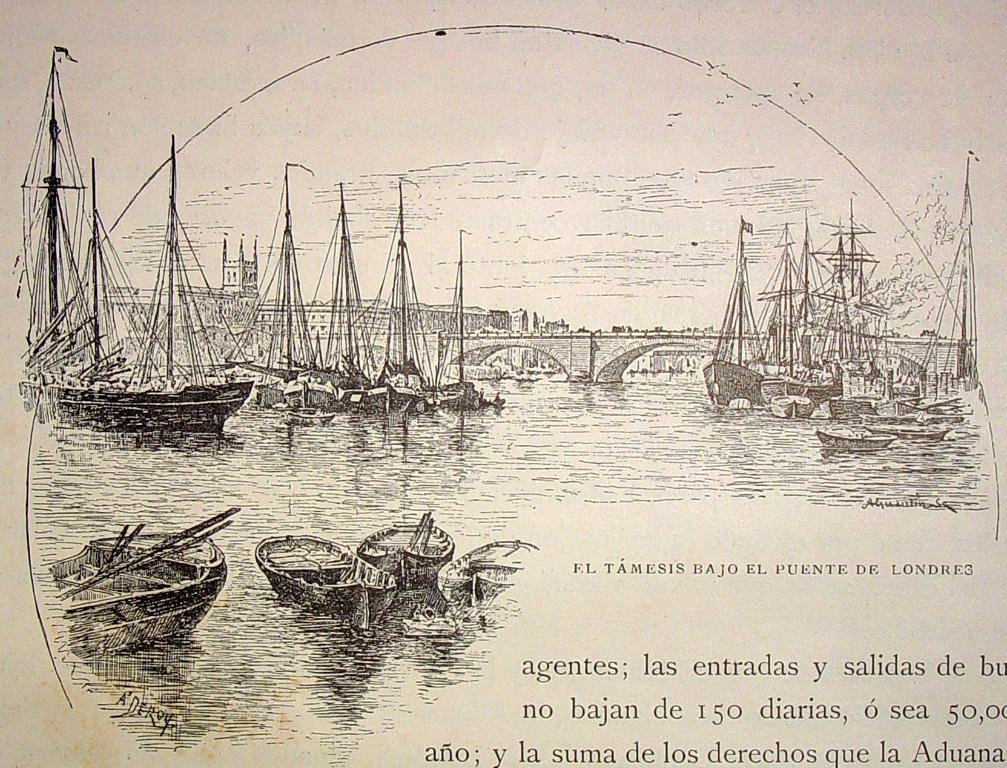What is the medium of the image? The image is a drawing. What is depicted in the center of the drawing? There are boats in a river in the center of the drawing. What structure is present in the drawing? There is a bridge in the drawing. What can be found at the bottom of the image? There is text at the bottom of the image. How many stars can be seen in the river in the image? There are no stars depicted in the river in the image; it features boats in a river and a bridge. What type of liquid is present in the boats in the image? The boats in the image are on a river, so the liquid present is water. However, the boats themselves are not filled with liquid. 